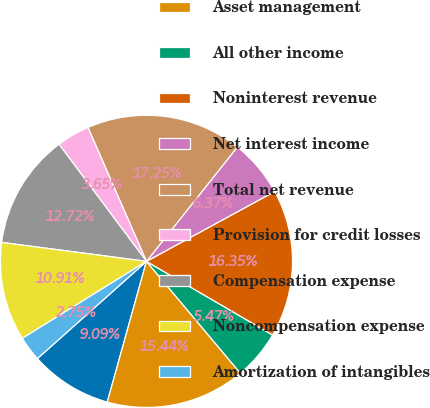Convert chart to OTSL. <chart><loc_0><loc_0><loc_500><loc_500><pie_chart><fcel>Year ended December 31 (in<fcel>Asset management<fcel>All other income<fcel>Noninterest revenue<fcel>Net interest income<fcel>Total net revenue<fcel>Provision for credit losses<fcel>Compensation expense<fcel>Noncompensation expense<fcel>Amortization of intangibles<nl><fcel>9.09%<fcel>15.44%<fcel>5.47%<fcel>16.35%<fcel>6.37%<fcel>17.25%<fcel>3.65%<fcel>12.72%<fcel>10.91%<fcel>2.75%<nl></chart> 